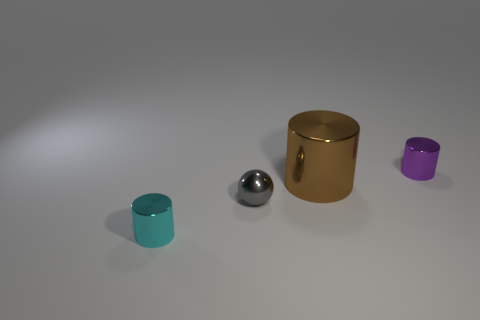Add 4 large green rubber cylinders. How many objects exist? 8 Subtract all cylinders. How many objects are left? 1 Add 1 brown metal things. How many brown metal things are left? 2 Add 2 tiny cyan objects. How many tiny cyan objects exist? 3 Subtract 0 blue cubes. How many objects are left? 4 Subtract all tiny brown rubber blocks. Subtract all brown metal things. How many objects are left? 3 